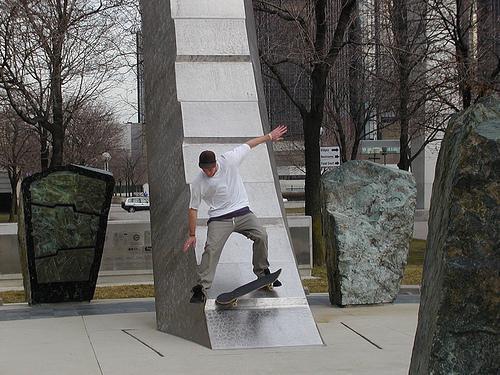How many boats are on the water?
Give a very brief answer. 0. 